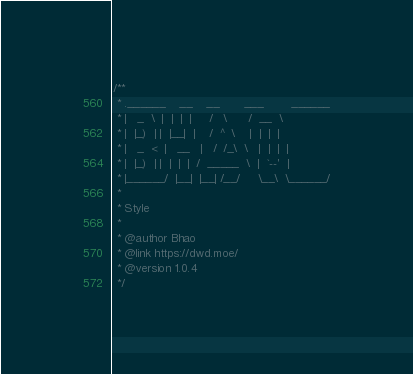Convert code to text. <code><loc_0><loc_0><loc_500><loc_500><_CSS_>/**
 * .______    __    __       ___        ______
 * |   _  \  |  |  |  |     /   \      /  __  \
 * |  |_)  | |  |__|  |    /  ^  \    |  |  |  |
 * |   _  <  |   __   |   /  /_\  \   |  |  |  |
 * |  |_)  | |  |  |  |  /  _____  \  |  `--'  |
 * |______/  |__|  |__| /__/     \__\  \______/
 * 
 * Style
 * 
 * @author Bhao
 * @link https://dwd.moe/
 * @version 1.0.4
 */</code> 